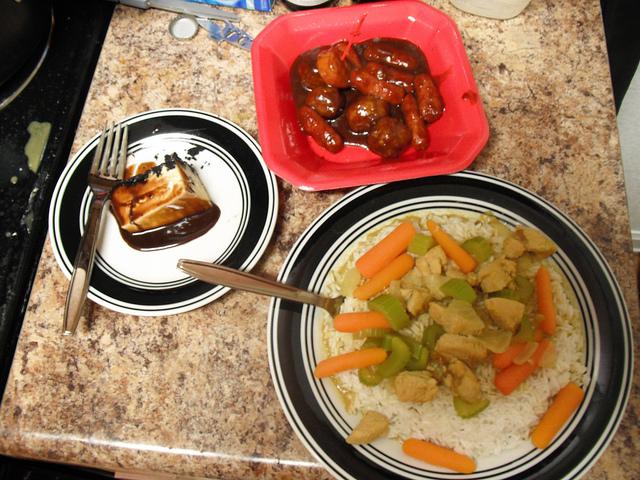Would you like to have a meal like that?
Be succinct. Yes. What material is the table made out of?
Be succinct. Granite. How many different foods are there?
Concise answer only. 3. What ingredients are in the rice dish?
Answer briefly. Carrots, celery, and chicken. 